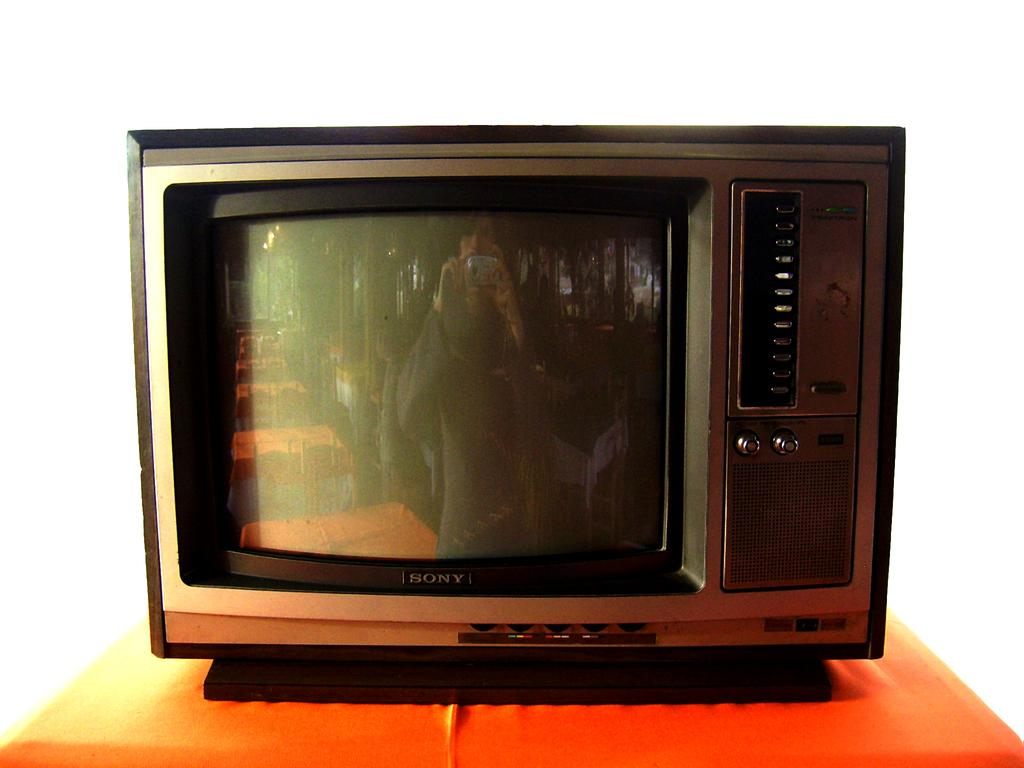<image>
Relay a brief, clear account of the picture shown. the word Sony is on the television in the room 